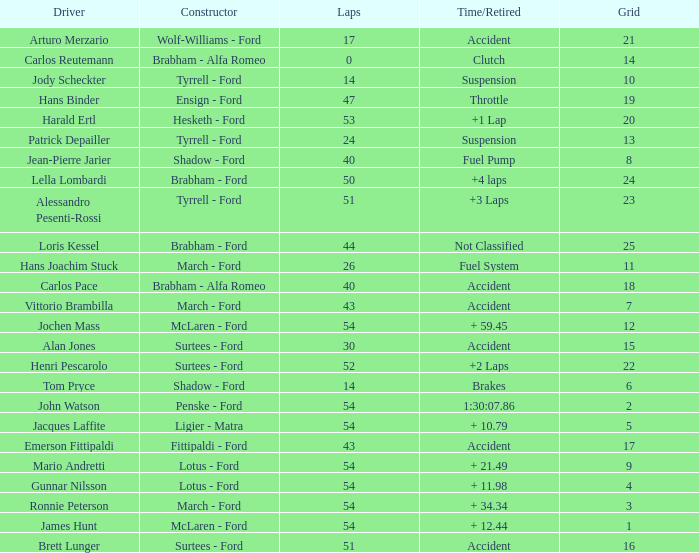What is the Time/Retired of Carlos Reutemann who was driving a brabham - Alfa Romeo? Clutch. Would you be able to parse every entry in this table? {'header': ['Driver', 'Constructor', 'Laps', 'Time/Retired', 'Grid'], 'rows': [['Arturo Merzario', 'Wolf-Williams - Ford', '17', 'Accident', '21'], ['Carlos Reutemann', 'Brabham - Alfa Romeo', '0', 'Clutch', '14'], ['Jody Scheckter', 'Tyrrell - Ford', '14', 'Suspension', '10'], ['Hans Binder', 'Ensign - Ford', '47', 'Throttle', '19'], ['Harald Ertl', 'Hesketh - Ford', '53', '+1 Lap', '20'], ['Patrick Depailler', 'Tyrrell - Ford', '24', 'Suspension', '13'], ['Jean-Pierre Jarier', 'Shadow - Ford', '40', 'Fuel Pump', '8'], ['Lella Lombardi', 'Brabham - Ford', '50', '+4 laps', '24'], ['Alessandro Pesenti-Rossi', 'Tyrrell - Ford', '51', '+3 Laps', '23'], ['Loris Kessel', 'Brabham - Ford', '44', 'Not Classified', '25'], ['Hans Joachim Stuck', 'March - Ford', '26', 'Fuel System', '11'], ['Carlos Pace', 'Brabham - Alfa Romeo', '40', 'Accident', '18'], ['Vittorio Brambilla', 'March - Ford', '43', 'Accident', '7'], ['Jochen Mass', 'McLaren - Ford', '54', '+ 59.45', '12'], ['Alan Jones', 'Surtees - Ford', '30', 'Accident', '15'], ['Henri Pescarolo', 'Surtees - Ford', '52', '+2 Laps', '22'], ['Tom Pryce', 'Shadow - Ford', '14', 'Brakes', '6'], ['John Watson', 'Penske - Ford', '54', '1:30:07.86', '2'], ['Jacques Laffite', 'Ligier - Matra', '54', '+ 10.79', '5'], ['Emerson Fittipaldi', 'Fittipaldi - Ford', '43', 'Accident', '17'], ['Mario Andretti', 'Lotus - Ford', '54', '+ 21.49', '9'], ['Gunnar Nilsson', 'Lotus - Ford', '54', '+ 11.98', '4'], ['Ronnie Peterson', 'March - Ford', '54', '+ 34.34', '3'], ['James Hunt', 'McLaren - Ford', '54', '+ 12.44', '1'], ['Brett Lunger', 'Surtees - Ford', '51', 'Accident', '16']]} 